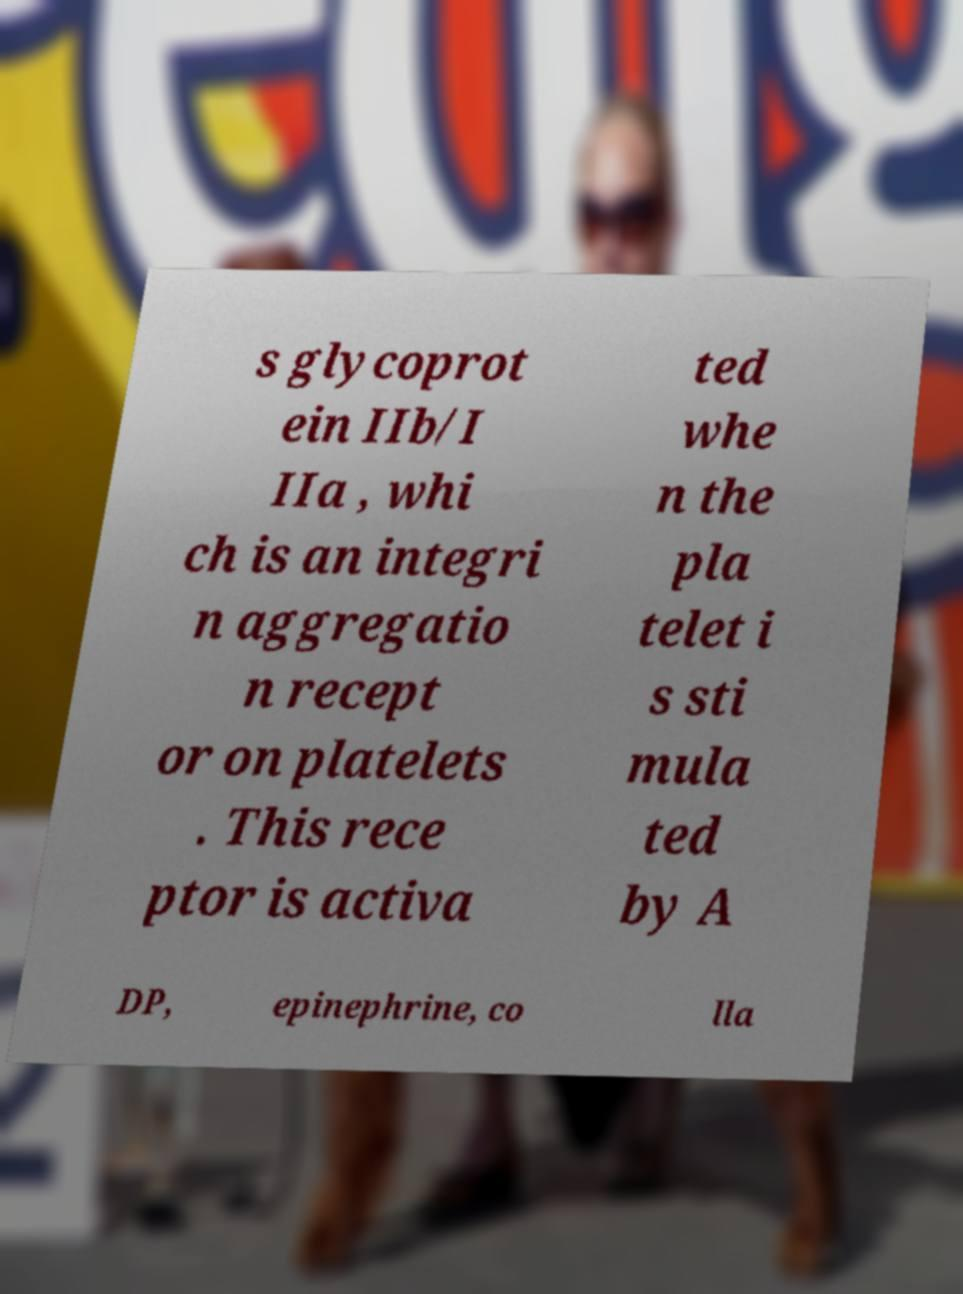Please identify and transcribe the text found in this image. s glycoprot ein IIb/I IIa , whi ch is an integri n aggregatio n recept or on platelets . This rece ptor is activa ted whe n the pla telet i s sti mula ted by A DP, epinephrine, co lla 